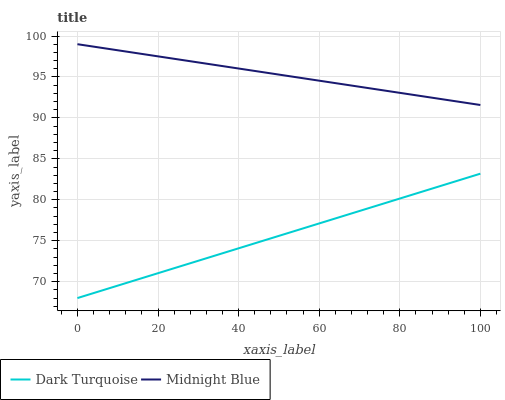Does Dark Turquoise have the minimum area under the curve?
Answer yes or no. Yes. Does Midnight Blue have the maximum area under the curve?
Answer yes or no. Yes. Does Midnight Blue have the minimum area under the curve?
Answer yes or no. No. Is Midnight Blue the smoothest?
Answer yes or no. Yes. Is Dark Turquoise the roughest?
Answer yes or no. Yes. Is Midnight Blue the roughest?
Answer yes or no. No. Does Dark Turquoise have the lowest value?
Answer yes or no. Yes. Does Midnight Blue have the lowest value?
Answer yes or no. No. Does Midnight Blue have the highest value?
Answer yes or no. Yes. Is Dark Turquoise less than Midnight Blue?
Answer yes or no. Yes. Is Midnight Blue greater than Dark Turquoise?
Answer yes or no. Yes. Does Dark Turquoise intersect Midnight Blue?
Answer yes or no. No. 